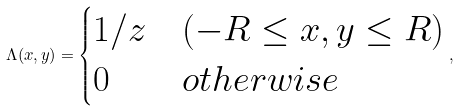<formula> <loc_0><loc_0><loc_500><loc_500>\Lambda ( x , y ) = \begin{cases} 1 / z & ( - R \leq x , y \leq R ) \\ 0 & o t h e r w i s e \end{cases} ,</formula> 